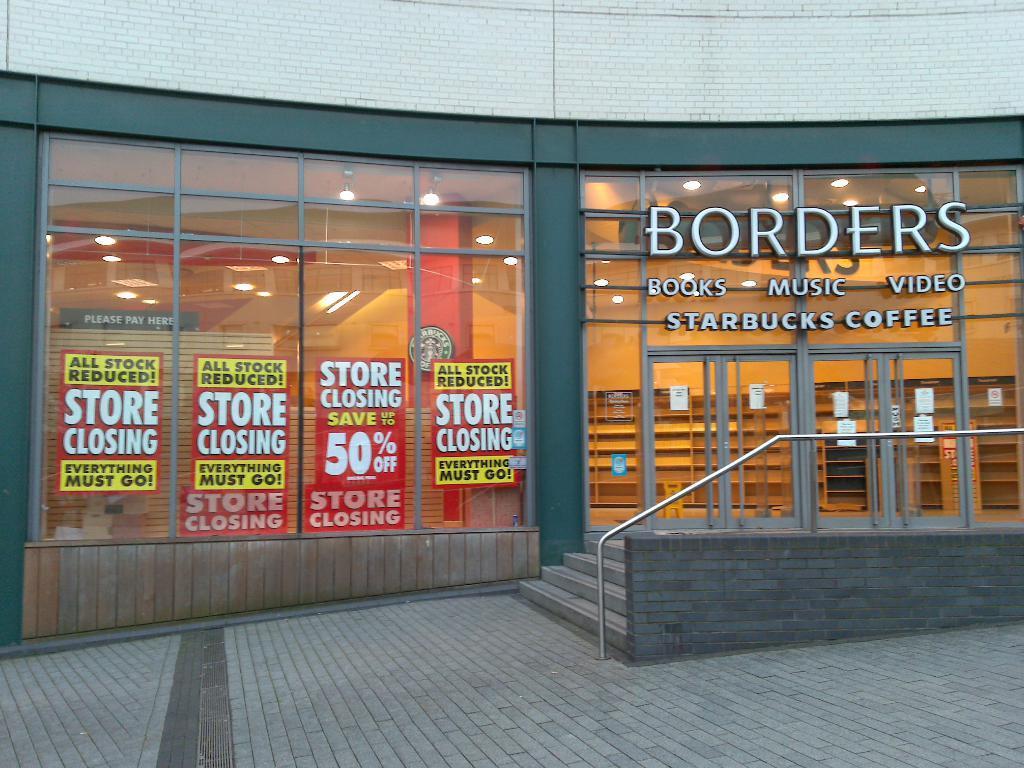Could you give a brief overview of what you see in this image? In this picture I can observe a building. I can observe some posters on the glass. On the right side there is a railing and glass doors. 